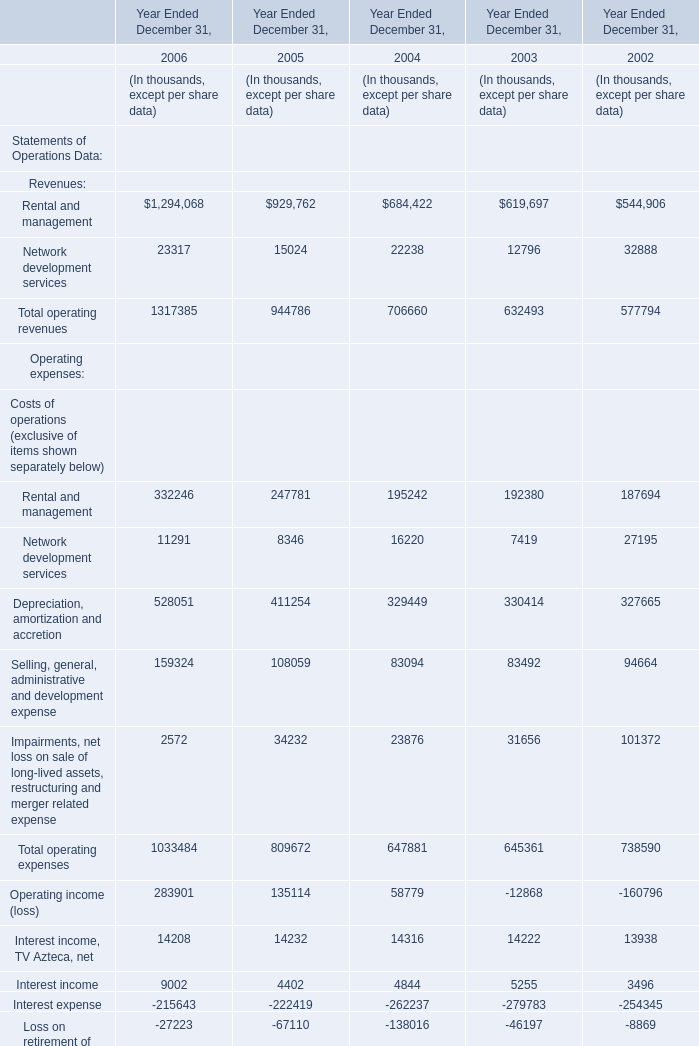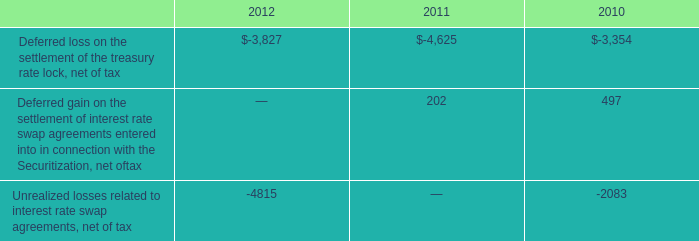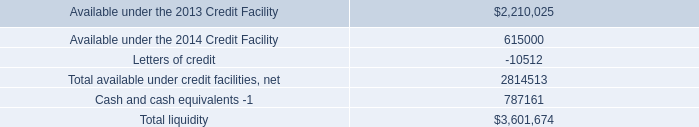What's the increasing rate of operating expenses in 2006? (in %) 
Computations: ((1033484 - 809672) / 809672)
Answer: 0.27642. 